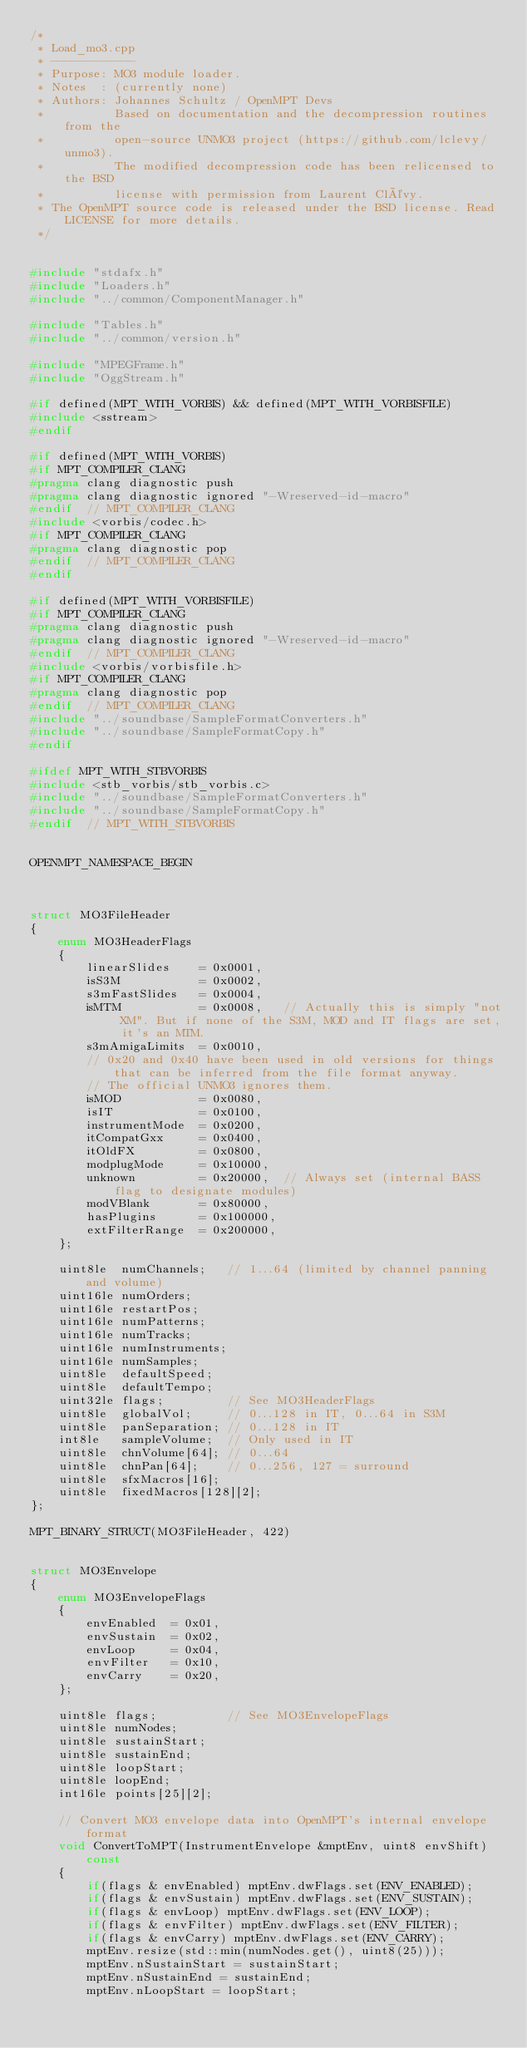Convert code to text. <code><loc_0><loc_0><loc_500><loc_500><_C++_>/*
 * Load_mo3.cpp
 * ------------
 * Purpose: MO3 module loader.
 * Notes  : (currently none)
 * Authors: Johannes Schultz / OpenMPT Devs
 *          Based on documentation and the decompression routines from the
 *          open-source UNMO3 project (https://github.com/lclevy/unmo3).
 *          The modified decompression code has been relicensed to the BSD
 *          license with permission from Laurent Clévy.
 * The OpenMPT source code is released under the BSD license. Read LICENSE for more details.
 */


#include "stdafx.h"
#include "Loaders.h"
#include "../common/ComponentManager.h"

#include "Tables.h"
#include "../common/version.h"

#include "MPEGFrame.h"
#include "OggStream.h"

#if defined(MPT_WITH_VORBIS) && defined(MPT_WITH_VORBISFILE)
#include <sstream>
#endif

#if defined(MPT_WITH_VORBIS)
#if MPT_COMPILER_CLANG
#pragma clang diagnostic push
#pragma clang diagnostic ignored "-Wreserved-id-macro"
#endif  // MPT_COMPILER_CLANG
#include <vorbis/codec.h>
#if MPT_COMPILER_CLANG
#pragma clang diagnostic pop
#endif  // MPT_COMPILER_CLANG
#endif

#if defined(MPT_WITH_VORBISFILE)
#if MPT_COMPILER_CLANG
#pragma clang diagnostic push
#pragma clang diagnostic ignored "-Wreserved-id-macro"
#endif  // MPT_COMPILER_CLANG
#include <vorbis/vorbisfile.h>
#if MPT_COMPILER_CLANG
#pragma clang diagnostic pop
#endif  // MPT_COMPILER_CLANG
#include "../soundbase/SampleFormatConverters.h"
#include "../soundbase/SampleFormatCopy.h"
#endif

#ifdef MPT_WITH_STBVORBIS
#include <stb_vorbis/stb_vorbis.c>
#include "../soundbase/SampleFormatConverters.h"
#include "../soundbase/SampleFormatCopy.h"
#endif  // MPT_WITH_STBVORBIS


OPENMPT_NAMESPACE_BEGIN



struct MO3FileHeader
{
	enum MO3HeaderFlags
	{
		linearSlides	= 0x0001,
		isS3M			= 0x0002,
		s3mFastSlides	= 0x0004,
		isMTM			= 0x0008,	// Actually this is simply "not XM". But if none of the S3M, MOD and IT flags are set, it's an MTM.
		s3mAmigaLimits	= 0x0010,
		// 0x20 and 0x40 have been used in old versions for things that can be inferred from the file format anyway.
		// The official UNMO3 ignores them.
		isMOD			= 0x0080,
		isIT			= 0x0100,
		instrumentMode	= 0x0200,
		itCompatGxx		= 0x0400,
		itOldFX			= 0x0800,
		modplugMode		= 0x10000,
		unknown			= 0x20000,	// Always set (internal BASS flag to designate modules)
		modVBlank		= 0x80000,
		hasPlugins		= 0x100000,
		extFilterRange	= 0x200000,
	};

	uint8le  numChannels;	// 1...64 (limited by channel panning and volume)
	uint16le numOrders;
	uint16le restartPos;
	uint16le numPatterns;
	uint16le numTracks;
	uint16le numInstruments;
	uint16le numSamples;
	uint8le  defaultSpeed;
	uint8le  defaultTempo;
	uint32le flags;			// See MO3HeaderFlags
	uint8le  globalVol;		// 0...128 in IT, 0...64 in S3M
	uint8le  panSeparation;	// 0...128 in IT
	int8le   sampleVolume;	// Only used in IT
	uint8le  chnVolume[64];	// 0...64
	uint8le  chnPan[64];	// 0...256, 127 = surround
	uint8le  sfxMacros[16];
	uint8le  fixedMacros[128][2];
};

MPT_BINARY_STRUCT(MO3FileHeader, 422)


struct MO3Envelope
{
	enum MO3EnvelopeFlags
	{
		envEnabled	= 0x01,
		envSustain	= 0x02,
		envLoop		= 0x04,
		envFilter	= 0x10,
		envCarry	= 0x20,
	};

	uint8le flags;			// See MO3EnvelopeFlags
	uint8le numNodes;
	uint8le sustainStart;
	uint8le sustainEnd;
	uint8le loopStart;
	uint8le loopEnd;
	int16le points[25][2];

	// Convert MO3 envelope data into OpenMPT's internal envelope format
	void ConvertToMPT(InstrumentEnvelope &mptEnv, uint8 envShift) const
	{
		if(flags & envEnabled) mptEnv.dwFlags.set(ENV_ENABLED);
		if(flags & envSustain) mptEnv.dwFlags.set(ENV_SUSTAIN);
		if(flags & envLoop) mptEnv.dwFlags.set(ENV_LOOP);
		if(flags & envFilter) mptEnv.dwFlags.set(ENV_FILTER);
		if(flags & envCarry) mptEnv.dwFlags.set(ENV_CARRY);
		mptEnv.resize(std::min(numNodes.get(), uint8(25)));
		mptEnv.nSustainStart = sustainStart;
		mptEnv.nSustainEnd = sustainEnd;
		mptEnv.nLoopStart = loopStart;</code> 